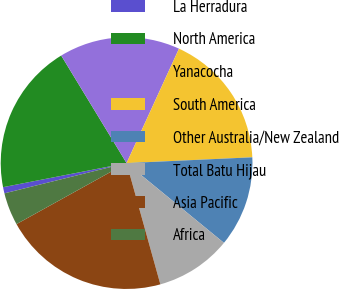Convert chart to OTSL. <chart><loc_0><loc_0><loc_500><loc_500><pie_chart><fcel>La Herradura<fcel>North America<fcel>Yanacocha<fcel>South America<fcel>Other Australia/New Zealand<fcel>Total Batu Hijau<fcel>Asia Pacific<fcel>Africa<nl><fcel>0.8%<fcel>19.37%<fcel>15.53%<fcel>17.43%<fcel>11.66%<fcel>9.75%<fcel>21.27%<fcel>4.19%<nl></chart> 